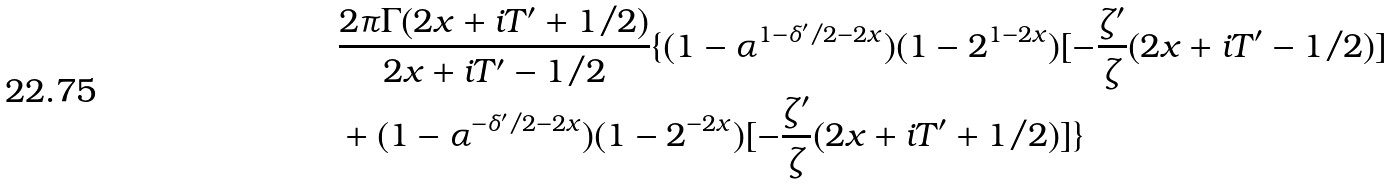<formula> <loc_0><loc_0><loc_500><loc_500>& \frac { 2 \pi \Gamma ( 2 x + i T ^ { \prime } + 1 / 2 ) } { 2 x + i T ^ { \prime } - 1 / 2 } \{ ( 1 - \alpha ^ { 1 - \delta ^ { \prime } / 2 - 2 x } ) ( 1 - 2 ^ { 1 - 2 x } ) [ - \frac { \zeta ^ { \prime } } { \zeta } ( 2 x + i T ^ { \prime } - 1 / 2 ) ] \\ & + ( 1 - \alpha ^ { - \delta ^ { \prime } / 2 - 2 x } ) ( 1 - 2 ^ { - 2 x } ) [ - \frac { \zeta ^ { \prime } } { \zeta } ( 2 x + i T ^ { \prime } + 1 / 2 ) ] \}</formula> 